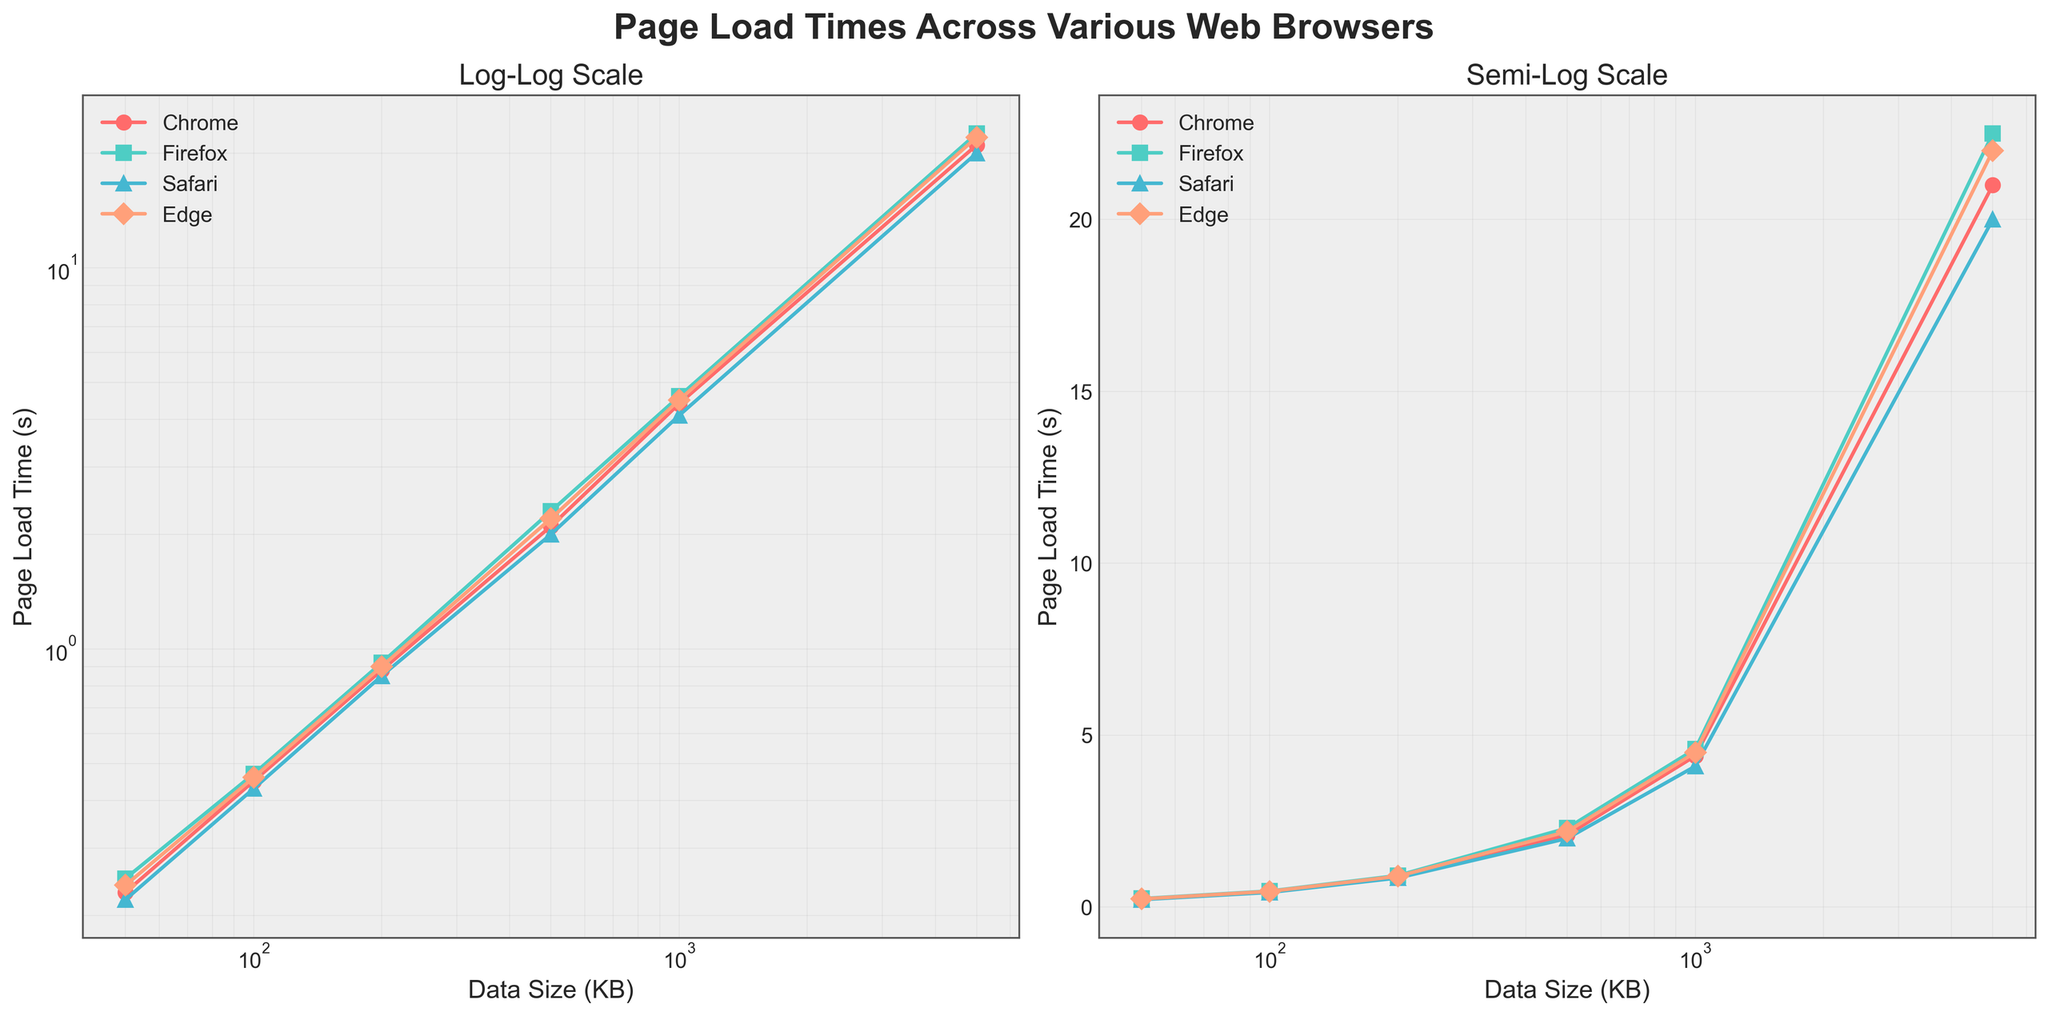What's the title of the figure? The title is located at the top of the figure. It reads "Page Load Times Across Various Web Browsers".
Answer: Page Load Times Across Various Web Browsers What are the labels on the x-axis and y-axis? The labels for the x-axis and y-axis are found on both plots. They are "Data Size (KB)" for the x-axis and "Page Load Time (s)" for the y-axis.
Answer: Data Size (KB) and Page Load Time (s) Which browser has the highest page load time for 5000 KB of data? Look at the data points for 5000 KB of data on both plots. The browser with the highest page load time is Firefox.
Answer: Firefox How many browsers are compared in this plot? By counting the legends or the distinct colors and markers, we can see that there are four browsers being compared (Chrome, Firefox, Safari, and Edge).
Answer: Four What scaling is used on the axes of the left subplot? The left subplot has both axes set to a logarithmic scale, indicated by "Log-Log Scale".
Answer: Logarithmic Among the browsers, which one shows the least variation in page load time as the data size increases? By comparing the spread of data points for each browser, Safari shows the least variation in page load time across different data sizes.
Answer: Safari At 100 KB data size, which browser loads the fastest? Locate the data point for 100 KB on the x-axis of either plot and find the browser with the lowest corresponding y-axis value. Chrome has the lowest page load time at 100 KB.
Answer: Chrome Compare the page load times for Chrome and Edge when the data size is 200 KB. Which one is faster and by how much? Locate the data points for 200 KB for both Chrome and Edge. Chrome's load time is 0.88s while Edge's is 0.9s. Chrome is faster by 0.02s.
Answer: Chrome by 0.02s What is the trend in page load times for all browsers as the data size increases? Observing the plots, as the data size increases, the page load times for all browsers increase as well.
Answer: Increase 